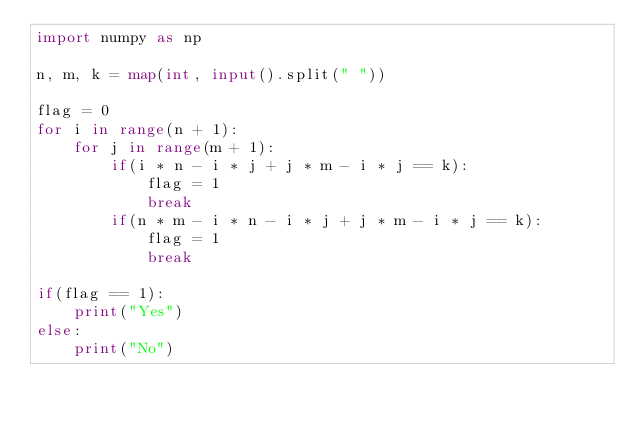<code> <loc_0><loc_0><loc_500><loc_500><_Python_>import numpy as np

n, m, k = map(int, input().split(" "))

flag = 0
for i in range(n + 1):
    for j in range(m + 1): 
        if(i * n - i * j + j * m - i * j == k):
            flag = 1
            break
        if(n * m - i * n - i * j + j * m - i * j == k):
            flag = 1
            break

if(flag == 1):
    print("Yes")
else:
    print("No")</code> 